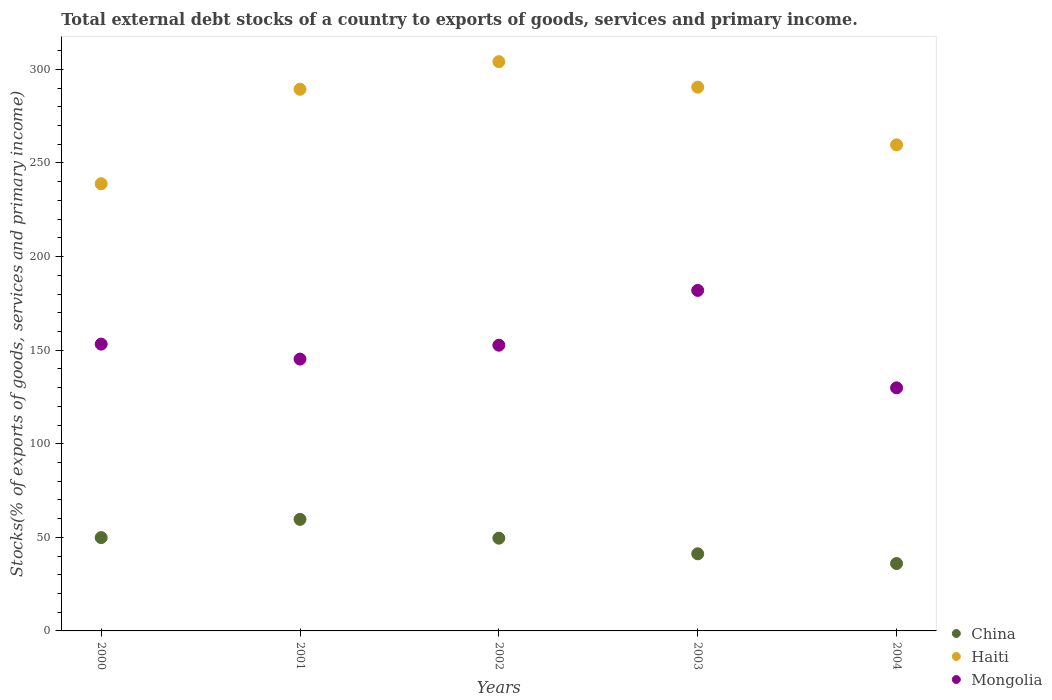What is the total debt stocks in China in 2000?
Keep it short and to the point. 49.86. Across all years, what is the maximum total debt stocks in Mongolia?
Ensure brevity in your answer.  181.92. Across all years, what is the minimum total debt stocks in China?
Keep it short and to the point. 36. In which year was the total debt stocks in Haiti maximum?
Provide a succinct answer. 2002. In which year was the total debt stocks in Mongolia minimum?
Your answer should be very brief. 2004. What is the total total debt stocks in Haiti in the graph?
Offer a terse response. 1382.63. What is the difference between the total debt stocks in China in 2001 and that in 2002?
Keep it short and to the point. 10.05. What is the difference between the total debt stocks in Mongolia in 2004 and the total debt stocks in Haiti in 2003?
Ensure brevity in your answer.  -160.63. What is the average total debt stocks in Mongolia per year?
Your answer should be compact. 152.58. In the year 2000, what is the difference between the total debt stocks in China and total debt stocks in Haiti?
Your response must be concise. -189.05. What is the ratio of the total debt stocks in Mongolia in 2000 to that in 2002?
Provide a short and direct response. 1. Is the total debt stocks in China in 2000 less than that in 2001?
Offer a terse response. Yes. What is the difference between the highest and the second highest total debt stocks in Mongolia?
Your answer should be compact. 28.69. What is the difference between the highest and the lowest total debt stocks in China?
Offer a terse response. 23.61. Does the total debt stocks in Mongolia monotonically increase over the years?
Ensure brevity in your answer.  No. Is the total debt stocks in Mongolia strictly greater than the total debt stocks in China over the years?
Your response must be concise. Yes. Is the total debt stocks in Haiti strictly less than the total debt stocks in Mongolia over the years?
Ensure brevity in your answer.  No. How many dotlines are there?
Your response must be concise. 3. What is the difference between two consecutive major ticks on the Y-axis?
Offer a terse response. 50. Are the values on the major ticks of Y-axis written in scientific E-notation?
Give a very brief answer. No. Does the graph contain any zero values?
Provide a short and direct response. No. Where does the legend appear in the graph?
Give a very brief answer. Bottom right. How many legend labels are there?
Provide a succinct answer. 3. What is the title of the graph?
Ensure brevity in your answer.  Total external debt stocks of a country to exports of goods, services and primary income. What is the label or title of the X-axis?
Offer a terse response. Years. What is the label or title of the Y-axis?
Make the answer very short. Stocks(% of exports of goods, services and primary income). What is the Stocks(% of exports of goods, services and primary income) of China in 2000?
Make the answer very short. 49.86. What is the Stocks(% of exports of goods, services and primary income) of Haiti in 2000?
Make the answer very short. 238.91. What is the Stocks(% of exports of goods, services and primary income) in Mongolia in 2000?
Give a very brief answer. 153.23. What is the Stocks(% of exports of goods, services and primary income) in China in 2001?
Provide a succinct answer. 59.61. What is the Stocks(% of exports of goods, services and primary income) in Haiti in 2001?
Offer a very short reply. 289.39. What is the Stocks(% of exports of goods, services and primary income) of Mongolia in 2001?
Provide a short and direct response. 145.24. What is the Stocks(% of exports of goods, services and primary income) in China in 2002?
Keep it short and to the point. 49.55. What is the Stocks(% of exports of goods, services and primary income) in Haiti in 2002?
Offer a terse response. 304.13. What is the Stocks(% of exports of goods, services and primary income) of Mongolia in 2002?
Offer a terse response. 152.65. What is the Stocks(% of exports of goods, services and primary income) in China in 2003?
Ensure brevity in your answer.  41.21. What is the Stocks(% of exports of goods, services and primary income) of Haiti in 2003?
Provide a short and direct response. 290.51. What is the Stocks(% of exports of goods, services and primary income) of Mongolia in 2003?
Provide a short and direct response. 181.92. What is the Stocks(% of exports of goods, services and primary income) in China in 2004?
Offer a very short reply. 36. What is the Stocks(% of exports of goods, services and primary income) in Haiti in 2004?
Offer a terse response. 259.69. What is the Stocks(% of exports of goods, services and primary income) in Mongolia in 2004?
Your answer should be very brief. 129.87. Across all years, what is the maximum Stocks(% of exports of goods, services and primary income) in China?
Offer a very short reply. 59.61. Across all years, what is the maximum Stocks(% of exports of goods, services and primary income) in Haiti?
Keep it short and to the point. 304.13. Across all years, what is the maximum Stocks(% of exports of goods, services and primary income) in Mongolia?
Your answer should be compact. 181.92. Across all years, what is the minimum Stocks(% of exports of goods, services and primary income) of China?
Give a very brief answer. 36. Across all years, what is the minimum Stocks(% of exports of goods, services and primary income) of Haiti?
Keep it short and to the point. 238.91. Across all years, what is the minimum Stocks(% of exports of goods, services and primary income) in Mongolia?
Give a very brief answer. 129.87. What is the total Stocks(% of exports of goods, services and primary income) of China in the graph?
Offer a terse response. 236.23. What is the total Stocks(% of exports of goods, services and primary income) of Haiti in the graph?
Offer a terse response. 1382.63. What is the total Stocks(% of exports of goods, services and primary income) of Mongolia in the graph?
Your response must be concise. 762.91. What is the difference between the Stocks(% of exports of goods, services and primary income) in China in 2000 and that in 2001?
Ensure brevity in your answer.  -9.74. What is the difference between the Stocks(% of exports of goods, services and primary income) of Haiti in 2000 and that in 2001?
Offer a terse response. -50.48. What is the difference between the Stocks(% of exports of goods, services and primary income) in Mongolia in 2000 and that in 2001?
Provide a succinct answer. 7.99. What is the difference between the Stocks(% of exports of goods, services and primary income) in China in 2000 and that in 2002?
Keep it short and to the point. 0.31. What is the difference between the Stocks(% of exports of goods, services and primary income) of Haiti in 2000 and that in 2002?
Keep it short and to the point. -65.22. What is the difference between the Stocks(% of exports of goods, services and primary income) in Mongolia in 2000 and that in 2002?
Offer a terse response. 0.58. What is the difference between the Stocks(% of exports of goods, services and primary income) in China in 2000 and that in 2003?
Make the answer very short. 8.65. What is the difference between the Stocks(% of exports of goods, services and primary income) of Haiti in 2000 and that in 2003?
Provide a short and direct response. -51.59. What is the difference between the Stocks(% of exports of goods, services and primary income) of Mongolia in 2000 and that in 2003?
Provide a short and direct response. -28.69. What is the difference between the Stocks(% of exports of goods, services and primary income) in China in 2000 and that in 2004?
Provide a succinct answer. 13.86. What is the difference between the Stocks(% of exports of goods, services and primary income) in Haiti in 2000 and that in 2004?
Your answer should be compact. -20.78. What is the difference between the Stocks(% of exports of goods, services and primary income) in Mongolia in 2000 and that in 2004?
Provide a short and direct response. 23.36. What is the difference between the Stocks(% of exports of goods, services and primary income) in China in 2001 and that in 2002?
Offer a very short reply. 10.05. What is the difference between the Stocks(% of exports of goods, services and primary income) in Haiti in 2001 and that in 2002?
Offer a very short reply. -14.74. What is the difference between the Stocks(% of exports of goods, services and primary income) in Mongolia in 2001 and that in 2002?
Your answer should be very brief. -7.41. What is the difference between the Stocks(% of exports of goods, services and primary income) in China in 2001 and that in 2003?
Your answer should be compact. 18.39. What is the difference between the Stocks(% of exports of goods, services and primary income) of Haiti in 2001 and that in 2003?
Ensure brevity in your answer.  -1.11. What is the difference between the Stocks(% of exports of goods, services and primary income) in Mongolia in 2001 and that in 2003?
Give a very brief answer. -36.69. What is the difference between the Stocks(% of exports of goods, services and primary income) in China in 2001 and that in 2004?
Offer a very short reply. 23.61. What is the difference between the Stocks(% of exports of goods, services and primary income) of Haiti in 2001 and that in 2004?
Make the answer very short. 29.71. What is the difference between the Stocks(% of exports of goods, services and primary income) in Mongolia in 2001 and that in 2004?
Offer a very short reply. 15.37. What is the difference between the Stocks(% of exports of goods, services and primary income) in China in 2002 and that in 2003?
Your answer should be compact. 8.34. What is the difference between the Stocks(% of exports of goods, services and primary income) in Haiti in 2002 and that in 2003?
Ensure brevity in your answer.  13.63. What is the difference between the Stocks(% of exports of goods, services and primary income) of Mongolia in 2002 and that in 2003?
Your response must be concise. -29.27. What is the difference between the Stocks(% of exports of goods, services and primary income) in China in 2002 and that in 2004?
Ensure brevity in your answer.  13.55. What is the difference between the Stocks(% of exports of goods, services and primary income) of Haiti in 2002 and that in 2004?
Provide a short and direct response. 44.44. What is the difference between the Stocks(% of exports of goods, services and primary income) of Mongolia in 2002 and that in 2004?
Offer a terse response. 22.78. What is the difference between the Stocks(% of exports of goods, services and primary income) of China in 2003 and that in 2004?
Ensure brevity in your answer.  5.22. What is the difference between the Stocks(% of exports of goods, services and primary income) of Haiti in 2003 and that in 2004?
Offer a terse response. 30.82. What is the difference between the Stocks(% of exports of goods, services and primary income) in Mongolia in 2003 and that in 2004?
Offer a very short reply. 52.05. What is the difference between the Stocks(% of exports of goods, services and primary income) in China in 2000 and the Stocks(% of exports of goods, services and primary income) in Haiti in 2001?
Your answer should be compact. -239.53. What is the difference between the Stocks(% of exports of goods, services and primary income) of China in 2000 and the Stocks(% of exports of goods, services and primary income) of Mongolia in 2001?
Make the answer very short. -95.38. What is the difference between the Stocks(% of exports of goods, services and primary income) in Haiti in 2000 and the Stocks(% of exports of goods, services and primary income) in Mongolia in 2001?
Keep it short and to the point. 93.68. What is the difference between the Stocks(% of exports of goods, services and primary income) in China in 2000 and the Stocks(% of exports of goods, services and primary income) in Haiti in 2002?
Provide a succinct answer. -254.27. What is the difference between the Stocks(% of exports of goods, services and primary income) of China in 2000 and the Stocks(% of exports of goods, services and primary income) of Mongolia in 2002?
Your answer should be very brief. -102.79. What is the difference between the Stocks(% of exports of goods, services and primary income) of Haiti in 2000 and the Stocks(% of exports of goods, services and primary income) of Mongolia in 2002?
Your answer should be compact. 86.26. What is the difference between the Stocks(% of exports of goods, services and primary income) of China in 2000 and the Stocks(% of exports of goods, services and primary income) of Haiti in 2003?
Your answer should be very brief. -240.64. What is the difference between the Stocks(% of exports of goods, services and primary income) in China in 2000 and the Stocks(% of exports of goods, services and primary income) in Mongolia in 2003?
Provide a short and direct response. -132.06. What is the difference between the Stocks(% of exports of goods, services and primary income) of Haiti in 2000 and the Stocks(% of exports of goods, services and primary income) of Mongolia in 2003?
Your answer should be very brief. 56.99. What is the difference between the Stocks(% of exports of goods, services and primary income) of China in 2000 and the Stocks(% of exports of goods, services and primary income) of Haiti in 2004?
Provide a short and direct response. -209.83. What is the difference between the Stocks(% of exports of goods, services and primary income) of China in 2000 and the Stocks(% of exports of goods, services and primary income) of Mongolia in 2004?
Your response must be concise. -80.01. What is the difference between the Stocks(% of exports of goods, services and primary income) in Haiti in 2000 and the Stocks(% of exports of goods, services and primary income) in Mongolia in 2004?
Offer a terse response. 109.04. What is the difference between the Stocks(% of exports of goods, services and primary income) in China in 2001 and the Stocks(% of exports of goods, services and primary income) in Haiti in 2002?
Offer a very short reply. -244.53. What is the difference between the Stocks(% of exports of goods, services and primary income) in China in 2001 and the Stocks(% of exports of goods, services and primary income) in Mongolia in 2002?
Provide a succinct answer. -93.04. What is the difference between the Stocks(% of exports of goods, services and primary income) in Haiti in 2001 and the Stocks(% of exports of goods, services and primary income) in Mongolia in 2002?
Your response must be concise. 136.75. What is the difference between the Stocks(% of exports of goods, services and primary income) of China in 2001 and the Stocks(% of exports of goods, services and primary income) of Haiti in 2003?
Offer a very short reply. -230.9. What is the difference between the Stocks(% of exports of goods, services and primary income) in China in 2001 and the Stocks(% of exports of goods, services and primary income) in Mongolia in 2003?
Keep it short and to the point. -122.32. What is the difference between the Stocks(% of exports of goods, services and primary income) in Haiti in 2001 and the Stocks(% of exports of goods, services and primary income) in Mongolia in 2003?
Ensure brevity in your answer.  107.47. What is the difference between the Stocks(% of exports of goods, services and primary income) in China in 2001 and the Stocks(% of exports of goods, services and primary income) in Haiti in 2004?
Offer a terse response. -200.08. What is the difference between the Stocks(% of exports of goods, services and primary income) in China in 2001 and the Stocks(% of exports of goods, services and primary income) in Mongolia in 2004?
Your answer should be compact. -70.27. What is the difference between the Stocks(% of exports of goods, services and primary income) of Haiti in 2001 and the Stocks(% of exports of goods, services and primary income) of Mongolia in 2004?
Give a very brief answer. 159.52. What is the difference between the Stocks(% of exports of goods, services and primary income) in China in 2002 and the Stocks(% of exports of goods, services and primary income) in Haiti in 2003?
Offer a terse response. -240.95. What is the difference between the Stocks(% of exports of goods, services and primary income) of China in 2002 and the Stocks(% of exports of goods, services and primary income) of Mongolia in 2003?
Provide a succinct answer. -132.37. What is the difference between the Stocks(% of exports of goods, services and primary income) in Haiti in 2002 and the Stocks(% of exports of goods, services and primary income) in Mongolia in 2003?
Your answer should be very brief. 122.21. What is the difference between the Stocks(% of exports of goods, services and primary income) of China in 2002 and the Stocks(% of exports of goods, services and primary income) of Haiti in 2004?
Ensure brevity in your answer.  -210.14. What is the difference between the Stocks(% of exports of goods, services and primary income) of China in 2002 and the Stocks(% of exports of goods, services and primary income) of Mongolia in 2004?
Your answer should be compact. -80.32. What is the difference between the Stocks(% of exports of goods, services and primary income) in Haiti in 2002 and the Stocks(% of exports of goods, services and primary income) in Mongolia in 2004?
Give a very brief answer. 174.26. What is the difference between the Stocks(% of exports of goods, services and primary income) of China in 2003 and the Stocks(% of exports of goods, services and primary income) of Haiti in 2004?
Your answer should be compact. -218.47. What is the difference between the Stocks(% of exports of goods, services and primary income) of China in 2003 and the Stocks(% of exports of goods, services and primary income) of Mongolia in 2004?
Your answer should be very brief. -88.66. What is the difference between the Stocks(% of exports of goods, services and primary income) of Haiti in 2003 and the Stocks(% of exports of goods, services and primary income) of Mongolia in 2004?
Your answer should be very brief. 160.63. What is the average Stocks(% of exports of goods, services and primary income) of China per year?
Provide a succinct answer. 47.25. What is the average Stocks(% of exports of goods, services and primary income) in Haiti per year?
Your response must be concise. 276.53. What is the average Stocks(% of exports of goods, services and primary income) of Mongolia per year?
Ensure brevity in your answer.  152.58. In the year 2000, what is the difference between the Stocks(% of exports of goods, services and primary income) of China and Stocks(% of exports of goods, services and primary income) of Haiti?
Provide a succinct answer. -189.05. In the year 2000, what is the difference between the Stocks(% of exports of goods, services and primary income) in China and Stocks(% of exports of goods, services and primary income) in Mongolia?
Make the answer very short. -103.37. In the year 2000, what is the difference between the Stocks(% of exports of goods, services and primary income) in Haiti and Stocks(% of exports of goods, services and primary income) in Mongolia?
Your answer should be compact. 85.68. In the year 2001, what is the difference between the Stocks(% of exports of goods, services and primary income) of China and Stocks(% of exports of goods, services and primary income) of Haiti?
Your response must be concise. -229.79. In the year 2001, what is the difference between the Stocks(% of exports of goods, services and primary income) in China and Stocks(% of exports of goods, services and primary income) in Mongolia?
Your answer should be compact. -85.63. In the year 2001, what is the difference between the Stocks(% of exports of goods, services and primary income) in Haiti and Stocks(% of exports of goods, services and primary income) in Mongolia?
Keep it short and to the point. 144.16. In the year 2002, what is the difference between the Stocks(% of exports of goods, services and primary income) in China and Stocks(% of exports of goods, services and primary income) in Haiti?
Give a very brief answer. -254.58. In the year 2002, what is the difference between the Stocks(% of exports of goods, services and primary income) of China and Stocks(% of exports of goods, services and primary income) of Mongolia?
Keep it short and to the point. -103.1. In the year 2002, what is the difference between the Stocks(% of exports of goods, services and primary income) of Haiti and Stocks(% of exports of goods, services and primary income) of Mongolia?
Make the answer very short. 151.48. In the year 2003, what is the difference between the Stocks(% of exports of goods, services and primary income) of China and Stocks(% of exports of goods, services and primary income) of Haiti?
Offer a very short reply. -249.29. In the year 2003, what is the difference between the Stocks(% of exports of goods, services and primary income) of China and Stocks(% of exports of goods, services and primary income) of Mongolia?
Your response must be concise. -140.71. In the year 2003, what is the difference between the Stocks(% of exports of goods, services and primary income) in Haiti and Stocks(% of exports of goods, services and primary income) in Mongolia?
Offer a terse response. 108.58. In the year 2004, what is the difference between the Stocks(% of exports of goods, services and primary income) of China and Stocks(% of exports of goods, services and primary income) of Haiti?
Provide a short and direct response. -223.69. In the year 2004, what is the difference between the Stocks(% of exports of goods, services and primary income) of China and Stocks(% of exports of goods, services and primary income) of Mongolia?
Provide a short and direct response. -93.87. In the year 2004, what is the difference between the Stocks(% of exports of goods, services and primary income) of Haiti and Stocks(% of exports of goods, services and primary income) of Mongolia?
Offer a terse response. 129.82. What is the ratio of the Stocks(% of exports of goods, services and primary income) of China in 2000 to that in 2001?
Keep it short and to the point. 0.84. What is the ratio of the Stocks(% of exports of goods, services and primary income) in Haiti in 2000 to that in 2001?
Offer a terse response. 0.83. What is the ratio of the Stocks(% of exports of goods, services and primary income) in Mongolia in 2000 to that in 2001?
Make the answer very short. 1.05. What is the ratio of the Stocks(% of exports of goods, services and primary income) of China in 2000 to that in 2002?
Give a very brief answer. 1.01. What is the ratio of the Stocks(% of exports of goods, services and primary income) in Haiti in 2000 to that in 2002?
Ensure brevity in your answer.  0.79. What is the ratio of the Stocks(% of exports of goods, services and primary income) of China in 2000 to that in 2003?
Your response must be concise. 1.21. What is the ratio of the Stocks(% of exports of goods, services and primary income) in Haiti in 2000 to that in 2003?
Provide a succinct answer. 0.82. What is the ratio of the Stocks(% of exports of goods, services and primary income) in Mongolia in 2000 to that in 2003?
Ensure brevity in your answer.  0.84. What is the ratio of the Stocks(% of exports of goods, services and primary income) of China in 2000 to that in 2004?
Give a very brief answer. 1.39. What is the ratio of the Stocks(% of exports of goods, services and primary income) in Mongolia in 2000 to that in 2004?
Ensure brevity in your answer.  1.18. What is the ratio of the Stocks(% of exports of goods, services and primary income) of China in 2001 to that in 2002?
Your response must be concise. 1.2. What is the ratio of the Stocks(% of exports of goods, services and primary income) in Haiti in 2001 to that in 2002?
Your answer should be compact. 0.95. What is the ratio of the Stocks(% of exports of goods, services and primary income) in Mongolia in 2001 to that in 2002?
Your response must be concise. 0.95. What is the ratio of the Stocks(% of exports of goods, services and primary income) in China in 2001 to that in 2003?
Your response must be concise. 1.45. What is the ratio of the Stocks(% of exports of goods, services and primary income) in Haiti in 2001 to that in 2003?
Your response must be concise. 1. What is the ratio of the Stocks(% of exports of goods, services and primary income) in Mongolia in 2001 to that in 2003?
Your answer should be compact. 0.8. What is the ratio of the Stocks(% of exports of goods, services and primary income) of China in 2001 to that in 2004?
Offer a terse response. 1.66. What is the ratio of the Stocks(% of exports of goods, services and primary income) of Haiti in 2001 to that in 2004?
Offer a very short reply. 1.11. What is the ratio of the Stocks(% of exports of goods, services and primary income) of Mongolia in 2001 to that in 2004?
Your response must be concise. 1.12. What is the ratio of the Stocks(% of exports of goods, services and primary income) in China in 2002 to that in 2003?
Make the answer very short. 1.2. What is the ratio of the Stocks(% of exports of goods, services and primary income) of Haiti in 2002 to that in 2003?
Your answer should be very brief. 1.05. What is the ratio of the Stocks(% of exports of goods, services and primary income) in Mongolia in 2002 to that in 2003?
Provide a succinct answer. 0.84. What is the ratio of the Stocks(% of exports of goods, services and primary income) of China in 2002 to that in 2004?
Your response must be concise. 1.38. What is the ratio of the Stocks(% of exports of goods, services and primary income) in Haiti in 2002 to that in 2004?
Give a very brief answer. 1.17. What is the ratio of the Stocks(% of exports of goods, services and primary income) in Mongolia in 2002 to that in 2004?
Ensure brevity in your answer.  1.18. What is the ratio of the Stocks(% of exports of goods, services and primary income) of China in 2003 to that in 2004?
Your response must be concise. 1.14. What is the ratio of the Stocks(% of exports of goods, services and primary income) in Haiti in 2003 to that in 2004?
Keep it short and to the point. 1.12. What is the ratio of the Stocks(% of exports of goods, services and primary income) in Mongolia in 2003 to that in 2004?
Ensure brevity in your answer.  1.4. What is the difference between the highest and the second highest Stocks(% of exports of goods, services and primary income) of China?
Keep it short and to the point. 9.74. What is the difference between the highest and the second highest Stocks(% of exports of goods, services and primary income) of Haiti?
Your answer should be very brief. 13.63. What is the difference between the highest and the second highest Stocks(% of exports of goods, services and primary income) of Mongolia?
Your answer should be very brief. 28.69. What is the difference between the highest and the lowest Stocks(% of exports of goods, services and primary income) of China?
Provide a succinct answer. 23.61. What is the difference between the highest and the lowest Stocks(% of exports of goods, services and primary income) of Haiti?
Your response must be concise. 65.22. What is the difference between the highest and the lowest Stocks(% of exports of goods, services and primary income) of Mongolia?
Your answer should be very brief. 52.05. 